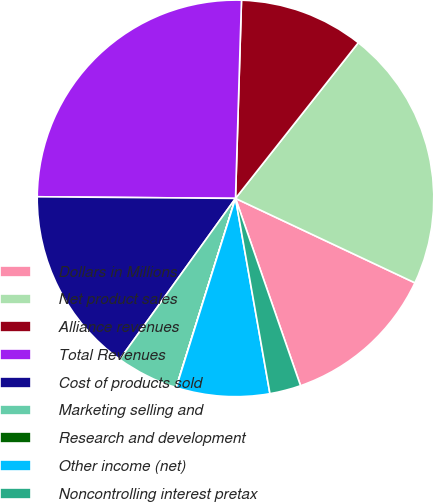<chart> <loc_0><loc_0><loc_500><loc_500><pie_chart><fcel>Dollars in Millions<fcel>Net product sales<fcel>Alliance revenues<fcel>Total Revenues<fcel>Cost of products sold<fcel>Marketing selling and<fcel>Research and development<fcel>Other income (net)<fcel>Noncontrolling interest pretax<nl><fcel>12.68%<fcel>21.37%<fcel>10.15%<fcel>25.35%<fcel>15.21%<fcel>5.08%<fcel>0.01%<fcel>7.61%<fcel>2.54%<nl></chart> 